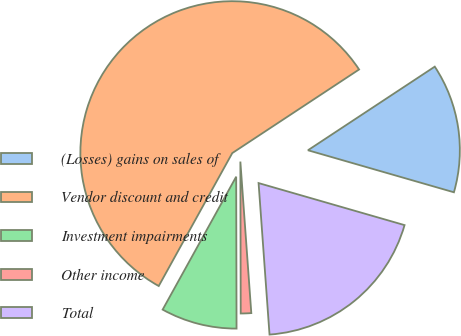Convert chart to OTSL. <chart><loc_0><loc_0><loc_500><loc_500><pie_chart><fcel>(Losses) gains on sales of<fcel>Vendor discount and credit<fcel>Investment impairments<fcel>Other income<fcel>Total<nl><fcel>13.74%<fcel>57.68%<fcel>8.08%<fcel>1.11%<fcel>19.39%<nl></chart> 